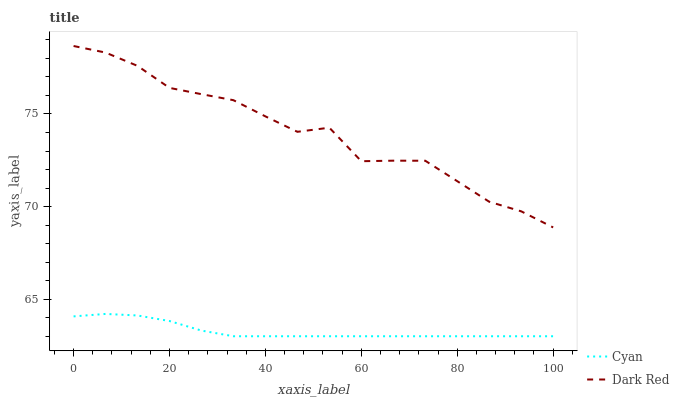Does Dark Red have the minimum area under the curve?
Answer yes or no. No. Is Dark Red the smoothest?
Answer yes or no. No. Does Dark Red have the lowest value?
Answer yes or no. No. Is Cyan less than Dark Red?
Answer yes or no. Yes. Is Dark Red greater than Cyan?
Answer yes or no. Yes. Does Cyan intersect Dark Red?
Answer yes or no. No. 